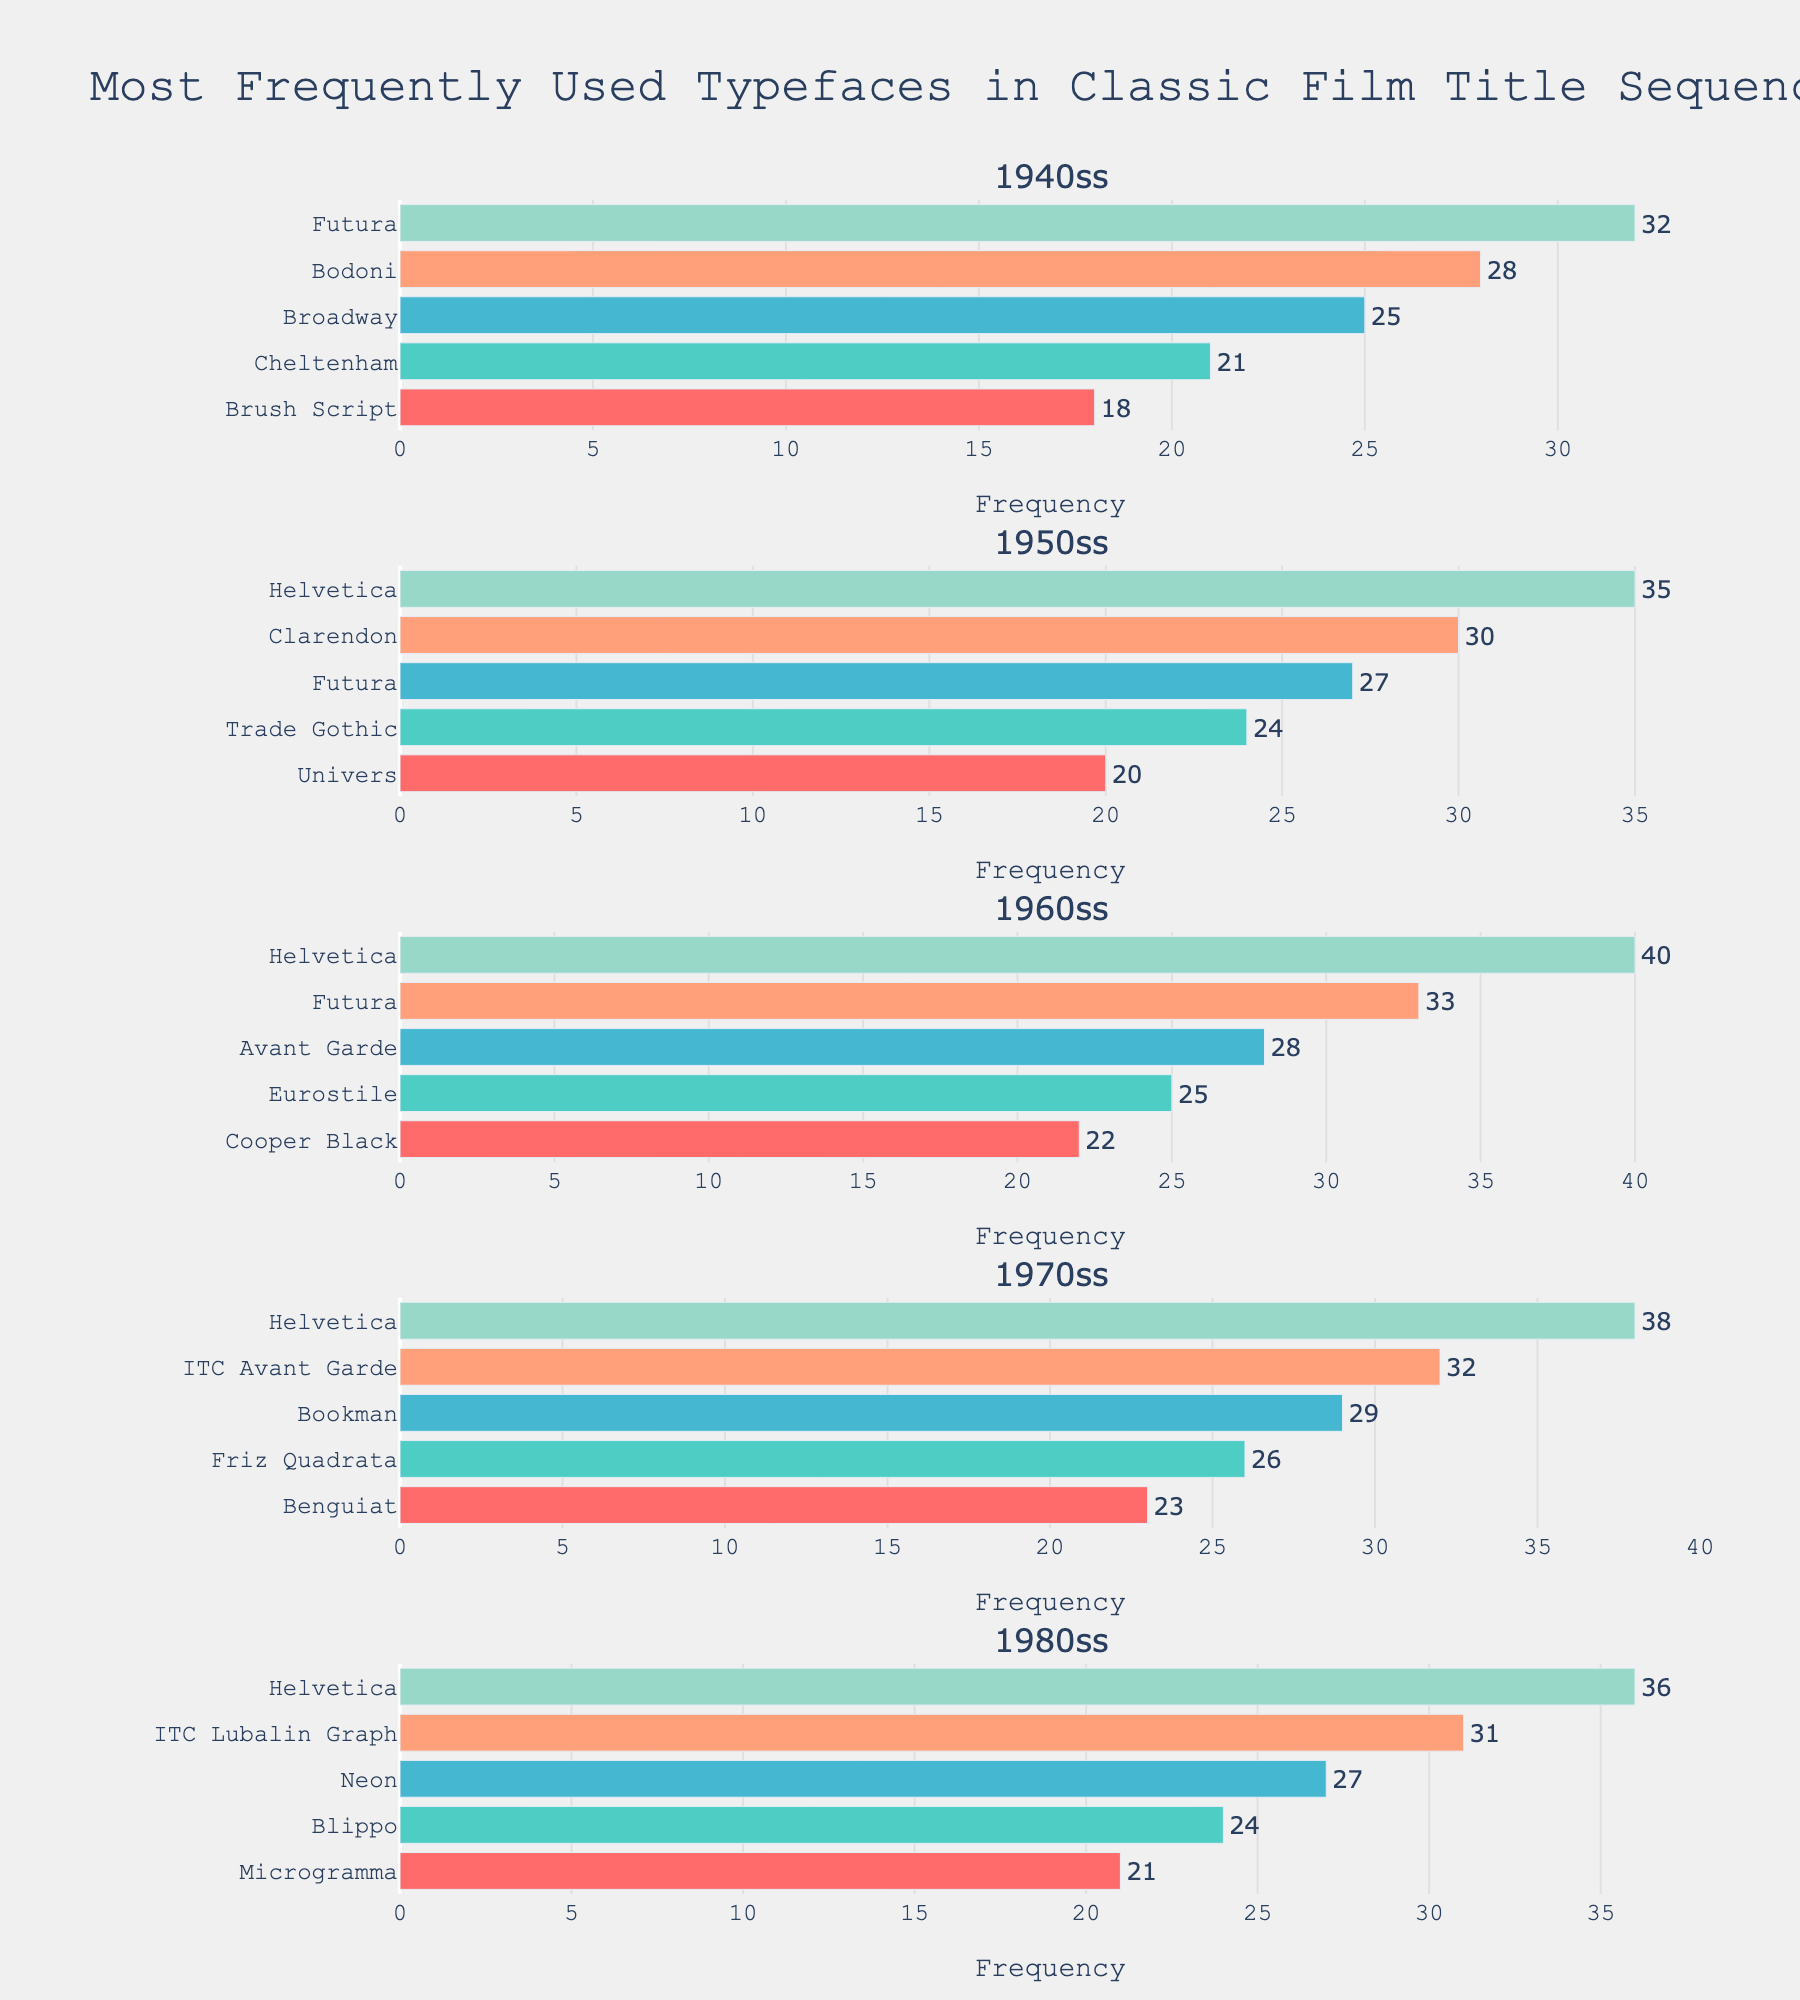What typeface was used the most frequently in the 1960s? According to the bar chart, Helvetica was used most frequently in the 1960s, reaching a frequency of 40.
Answer: Helvetica Which decade saw the most consistent use of one particular typeface? By comparing the frequencies across decades, we see that Helvetica was consistently the most used typeface with the highest frequency recorded in the 1950s, 1960s, 1970s, and 1980s.
Answer: 1960s How does the use of Futura in the 1950s compare to its use in the 1940s? Futura was used 27 times in the 1950s compared to 32 times in the 1940s, showing a reduction of 5.
Answer: 27 vs. 32 Which typeface had the highest frequency in the 1940s, and what was its value? Futura was the most frequently used typeface in the 1940s, with a frequency of 32.
Answer: Futura, 32 What is the sum of the frequencies of all typefaces used in the 1980s? Summing the frequencies of all typefaces used in the 1980s (36 + 31 + 27 + 24 + 21) yields 139.
Answer: 139 Compare the usage of Clarendon in the 1950s to Cooper Black in the 1960s. Which was used more frequently? Clarendon was used 30 times in the 1950s, while Cooper Black was used 22 times in the 1960s, indicating Clarendon was used more frequently.
Answer: Clarendon Which typefaces had the exact same frequency in different decades, if any? No typefaces have an exact matching frequency in different decades according to the chart.
Answer: None Among the typefaces listed for the 1970s, which one had the highest frequency increase compared to its usage in the 1960s? By comparing each typeface, ITC Avant Garde in the 1970s had an increased usage to 32 from 28 in the 1960s, the highest increase of 4.
Answer: ITC Avant Garde Which typeface appears in every decade's list from the 1940s to the 1980s? Helvetica is the typeface that appears in every decade's list from the 1940s to the 1980s.
Answer: Helvetica 